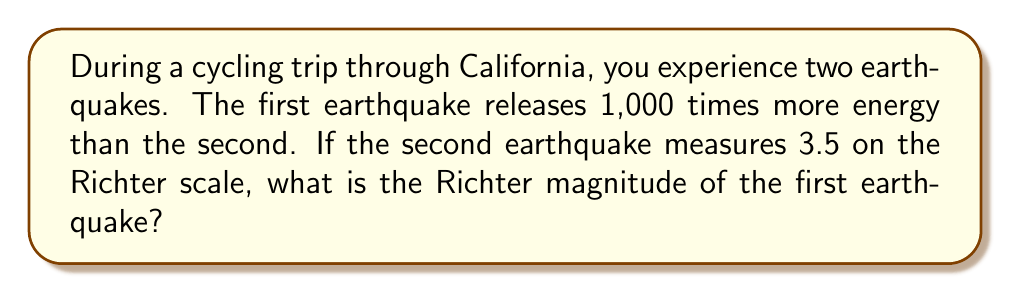Solve this math problem. Let's approach this step-by-step:

1) The Richter scale is logarithmic, based on the equation:

   $M = \log_{10}(A) + C$

   Where $M$ is the magnitude, $A$ is the amplitude of the waves, and $C$ is a constant.

2) The difference in magnitude between two earthquakes is related to the ratio of their energies:

   $M_1 - M_2 = \log_{10}(\frac{E_1}{E_2})$

   Where $M_1$ and $M_2$ are the magnitudes, and $E_1$ and $E_2$ are the energies of the two earthquakes.

3) We're told that the first earthquake releases 1,000 times more energy than the second. So:

   $\frac{E_1}{E_2} = 1000$

4) Let $M_1$ be the magnitude of the first (stronger) earthquake and $M_2$ be the magnitude of the second (weaker) earthquake. We know $M_2 = 3.5$. We can write:

   $M_1 - 3.5 = \log_{10}(1000)$

5) Simplify the right side:

   $M_1 - 3.5 = 3$

6) Solve for $M_1$:

   $M_1 = 3.5 + 3 = 6.5$

Therefore, the magnitude of the first earthquake is 6.5 on the Richter scale.
Answer: 6.5 